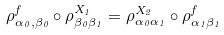<formula> <loc_0><loc_0><loc_500><loc_500>\rho ^ { f } _ { \alpha _ { 0 } , \beta _ { 0 } } \circ \rho ^ { X _ { 1 } } _ { \beta _ { 0 } \beta _ { 1 } } = \rho ^ { X _ { 2 } } _ { \alpha _ { 0 } \alpha _ { 1 } } \circ \rho ^ { f } _ { \alpha _ { 1 } \beta _ { 1 } }</formula> 